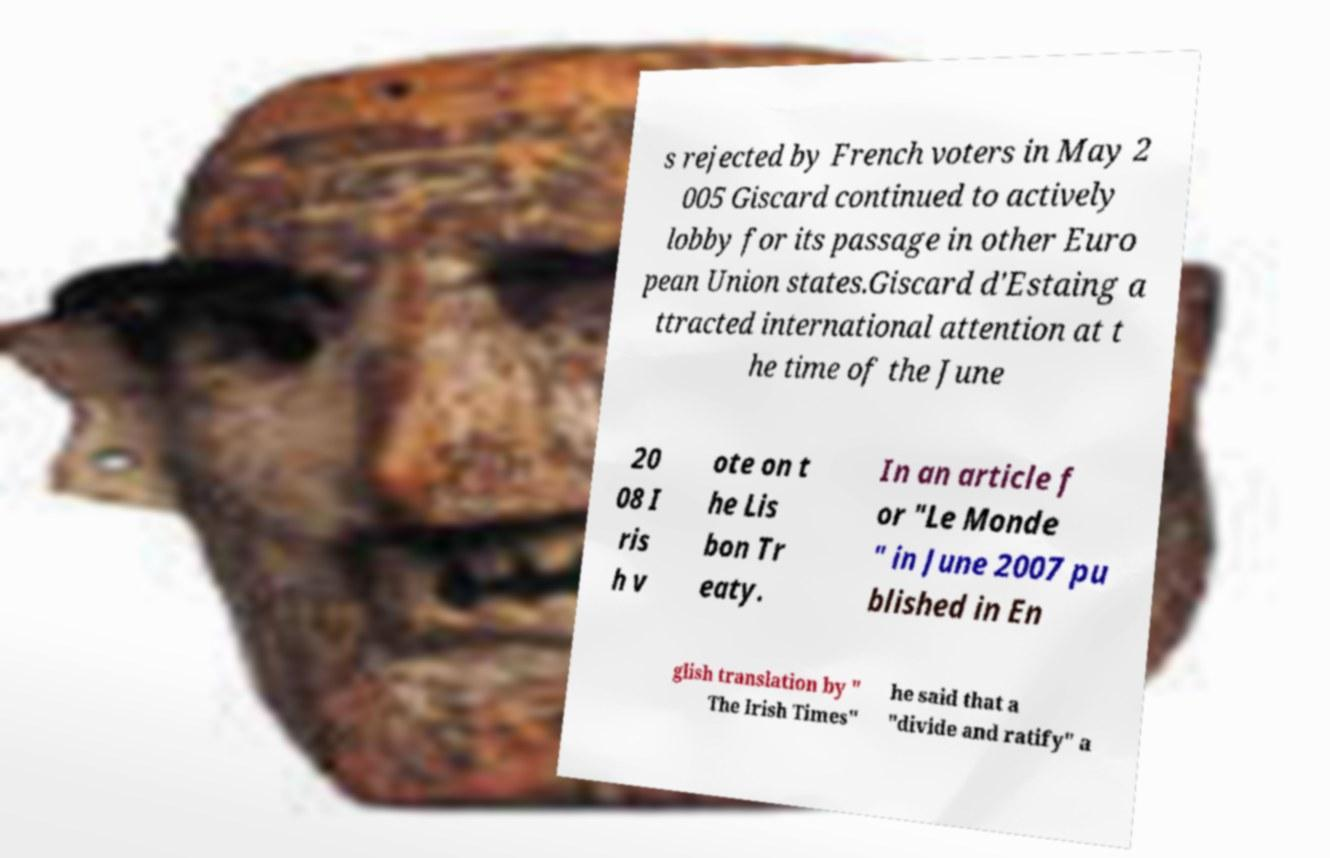I need the written content from this picture converted into text. Can you do that? s rejected by French voters in May 2 005 Giscard continued to actively lobby for its passage in other Euro pean Union states.Giscard d'Estaing a ttracted international attention at t he time of the June 20 08 I ris h v ote on t he Lis bon Tr eaty. In an article f or "Le Monde " in June 2007 pu blished in En glish translation by " The Irish Times" he said that a "divide and ratify" a 